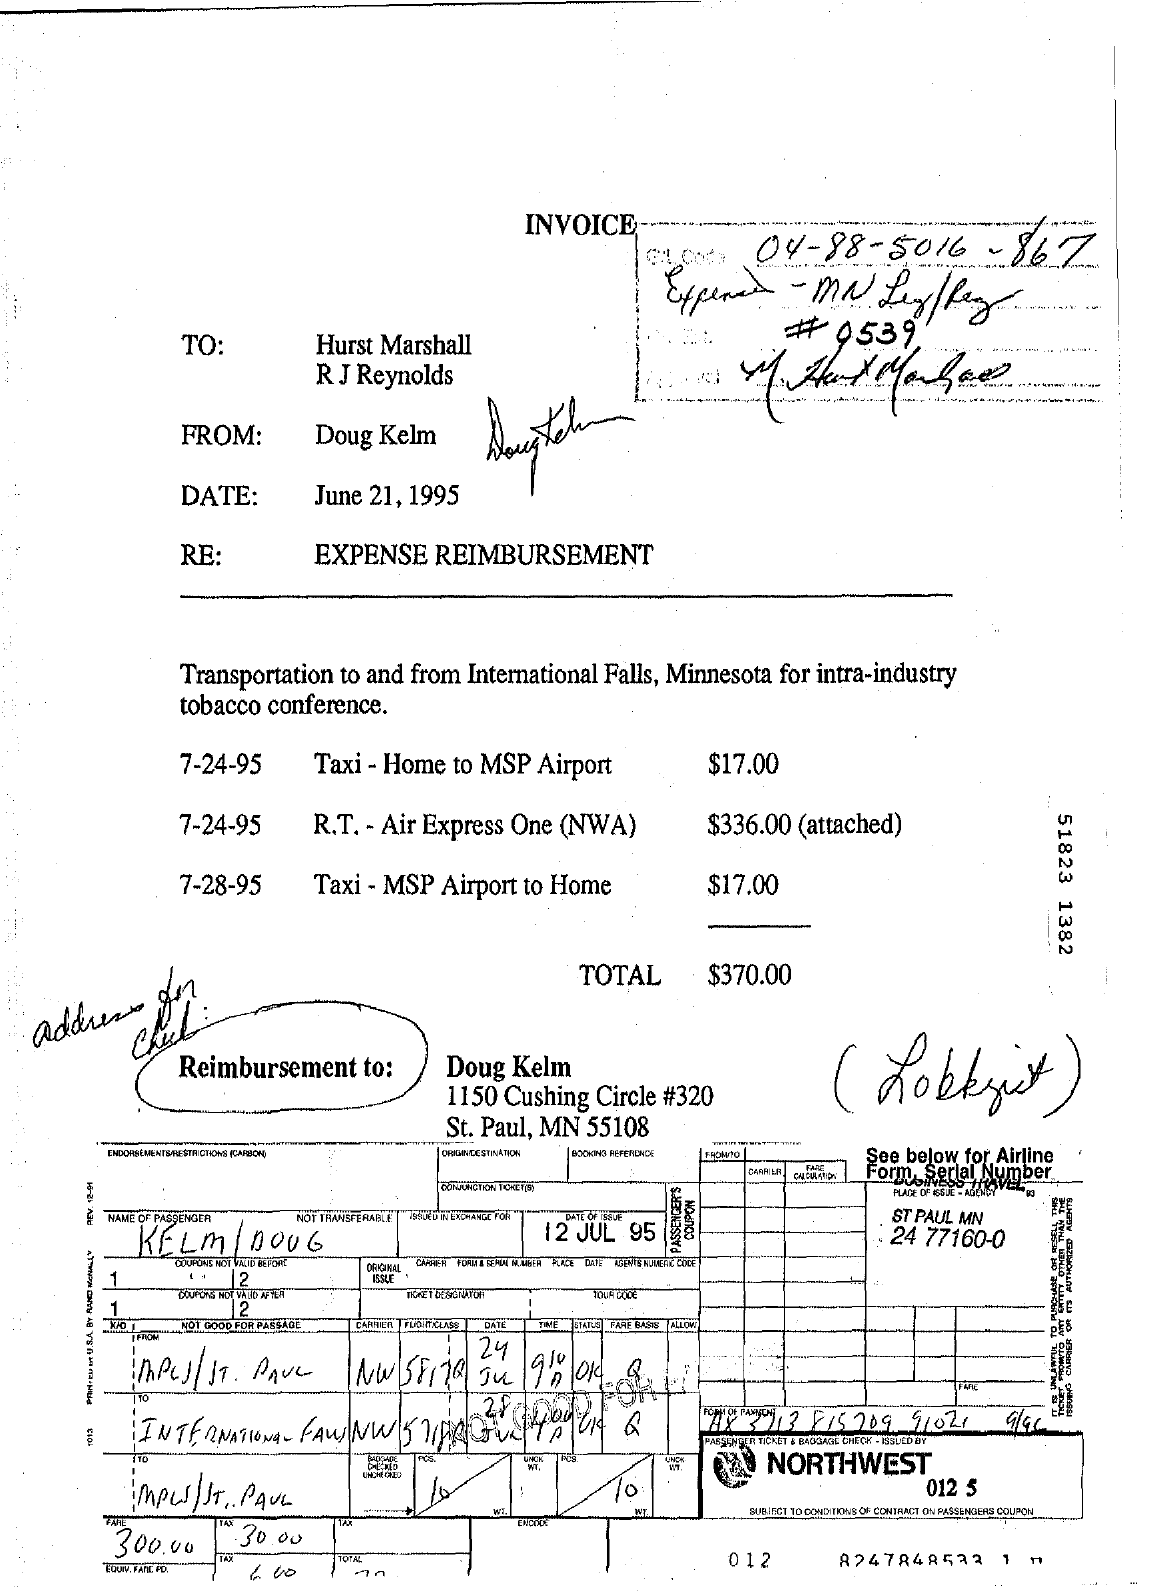Who is the sender?
Your answer should be very brief. Doug Kelm. When is the letter dated?
Your response must be concise. June 21, 1995. What is written on the RE field?
Your answer should be very brief. Expense Reimbursement. What is the total expense mentioned?
Provide a short and direct response. $370.00. 